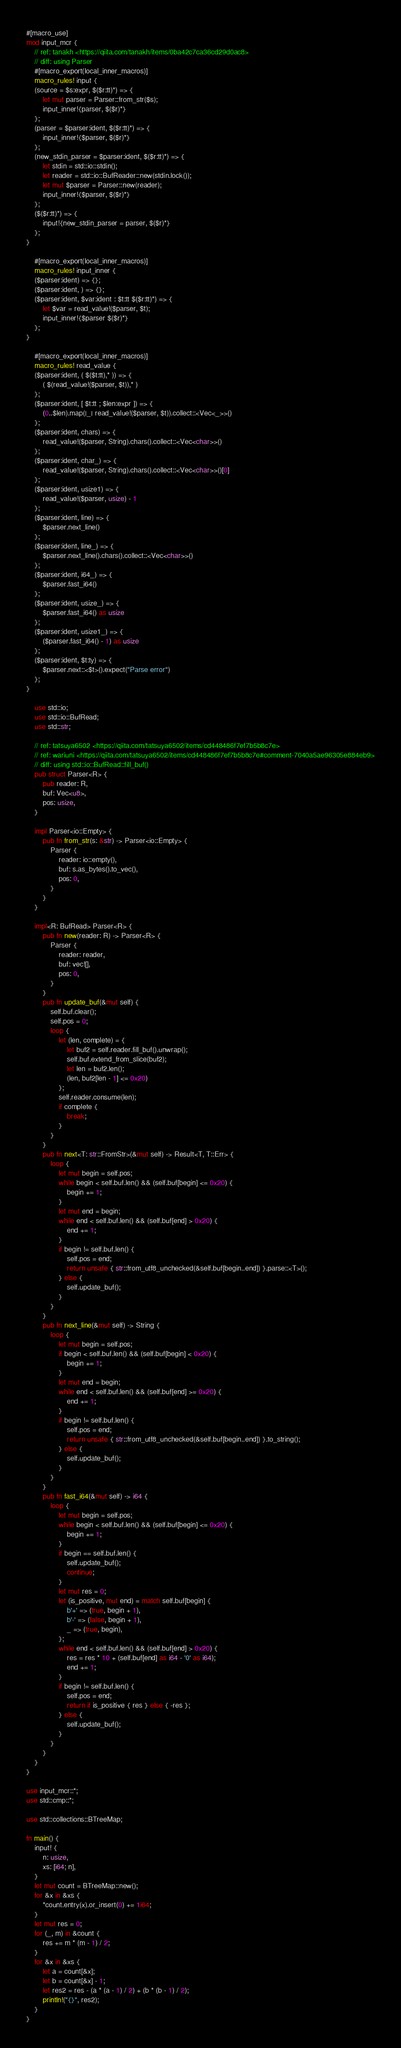<code> <loc_0><loc_0><loc_500><loc_500><_Rust_>#[macro_use]
mod input_mcr {
    // ref: tanakh <https://qiita.com/tanakh/items/0ba42c7ca36cd29d0ac8>
    // diff: using Parser
    #[macro_export(local_inner_macros)]
    macro_rules! input {
    (source = $s:expr, $($r:tt)*) => {
        let mut parser = Parser::from_str($s);
        input_inner!{parser, $($r)*}
    };
    (parser = $parser:ident, $($r:tt)*) => {
        input_inner!{$parser, $($r)*}
    };
    (new_stdin_parser = $parser:ident, $($r:tt)*) => {
        let stdin = std::io::stdin();
        let reader = std::io::BufReader::new(stdin.lock());
        let mut $parser = Parser::new(reader);
        input_inner!{$parser, $($r)*}
    };
    ($($r:tt)*) => {
        input!{new_stdin_parser = parser, $($r)*}
    };
}

    #[macro_export(local_inner_macros)]
    macro_rules! input_inner {
    ($parser:ident) => {};
    ($parser:ident, ) => {};
    ($parser:ident, $var:ident : $t:tt $($r:tt)*) => {
        let $var = read_value!($parser, $t);
        input_inner!{$parser $($r)*}
    };
}

    #[macro_export(local_inner_macros)]
    macro_rules! read_value {
    ($parser:ident, ( $($t:tt),* )) => {
        ( $(read_value!($parser, $t)),* )
    };
    ($parser:ident, [ $t:tt ; $len:expr ]) => {
        (0..$len).map(|_| read_value!($parser, $t)).collect::<Vec<_>>()
    };
    ($parser:ident, chars) => {
        read_value!($parser, String).chars().collect::<Vec<char>>()
    };
    ($parser:ident, char_) => {
        read_value!($parser, String).chars().collect::<Vec<char>>()[0]
    };
    ($parser:ident, usize1) => {
        read_value!($parser, usize) - 1
    };
    ($parser:ident, line) => {
        $parser.next_line()
    };
    ($parser:ident, line_) => {
        $parser.next_line().chars().collect::<Vec<char>>()
    };
    ($parser:ident, i64_) => {
        $parser.fast_i64()
    };
    ($parser:ident, usize_) => {
        $parser.fast_i64() as usize
    };
    ($parser:ident, usize1_) => {
        ($parser.fast_i64() - 1) as usize
    };
    ($parser:ident, $t:ty) => {
        $parser.next::<$t>().expect("Parse error")
    };
}

    use std::io;
    use std::io::BufRead;
    use std::str;

    // ref: tatsuya6502 <https://qiita.com/tatsuya6502/items/cd448486f7ef7b5b8c7e>
    // ref: wariuni <https://qiita.com/tatsuya6502/items/cd448486f7ef7b5b8c7e#comment-7040a5ae96305e884eb9>
    // diff: using std::io::BufRead::fill_buf()
    pub struct Parser<R> {
        pub reader: R,
        buf: Vec<u8>,
        pos: usize,
    }

    impl Parser<io::Empty> {
        pub fn from_str(s: &str) -> Parser<io::Empty> {
            Parser {
                reader: io::empty(),
                buf: s.as_bytes().to_vec(),
                pos: 0,
            }
        }
    }

    impl<R: BufRead> Parser<R> {
        pub fn new(reader: R) -> Parser<R> {
            Parser {
                reader: reader,
                buf: vec![],
                pos: 0,
            }
        }
        pub fn update_buf(&mut self) {
            self.buf.clear();
            self.pos = 0;
            loop {
                let (len, complete) = {
                    let buf2 = self.reader.fill_buf().unwrap();
                    self.buf.extend_from_slice(buf2);
                    let len = buf2.len();
                    (len, buf2[len - 1] <= 0x20)
                };
                self.reader.consume(len);
                if complete {
                    break;
                }
            }
        }
        pub fn next<T: str::FromStr>(&mut self) -> Result<T, T::Err> {
            loop {
                let mut begin = self.pos;
                while begin < self.buf.len() && (self.buf[begin] <= 0x20) {
                    begin += 1;
                }
                let mut end = begin;
                while end < self.buf.len() && (self.buf[end] > 0x20) {
                    end += 1;
                }
                if begin != self.buf.len() {
                    self.pos = end;
                    return unsafe { str::from_utf8_unchecked(&self.buf[begin..end]) }.parse::<T>();
                } else {
                    self.update_buf();
                }
            }
        }
        pub fn next_line(&mut self) -> String {
            loop {
                let mut begin = self.pos;
                if begin < self.buf.len() && (self.buf[begin] < 0x20) {
                    begin += 1;
                }
                let mut end = begin;
                while end < self.buf.len() && (self.buf[end] >= 0x20) {
                    end += 1;
                }
                if begin != self.buf.len() {
                    self.pos = end;
                    return unsafe { str::from_utf8_unchecked(&self.buf[begin..end]) }.to_string();
                } else {
                    self.update_buf();
                }
            }
        }
        pub fn fast_i64(&mut self) -> i64 {
            loop {
                let mut begin = self.pos;
                while begin < self.buf.len() && (self.buf[begin] <= 0x20) {
                    begin += 1;
                }
                if begin == self.buf.len() {
                    self.update_buf();
                    continue;
                }
                let mut res = 0;
                let (is_positive, mut end) = match self.buf[begin] {
                    b'+' => (true, begin + 1),
                    b'-' => (false, begin + 1),
                    _ => (true, begin),
                };
                while end < self.buf.len() && (self.buf[end] > 0x20) {
                    res = res * 10 + (self.buf[end] as i64 - '0' as i64);
                    end += 1;
                }
                if begin != self.buf.len() {
                    self.pos = end;
                    return if is_positive { res } else { -res };
                } else {
                    self.update_buf();
                }
            }
        }
    }
}

use input_mcr::*;
use std::cmp::*;

use std::collections::BTreeMap;

fn main() {
    input! {
        n: usize,
        xs: [i64; n],
    }
    let mut count = BTreeMap::new();
    for &x in &xs {
        *count.entry(x).or_insert(0) += 1i64;
    }
    let mut res = 0;
    for (_, m) in &count {
        res += m * (m - 1) / 2;
    }
    for &x in &xs {
        let a = count[&x];
        let b = count[&x] - 1;
        let res2 = res - (a * (a - 1) / 2) + (b * (b - 1) / 2);
        println!("{}", res2);
    }
}

</code> 